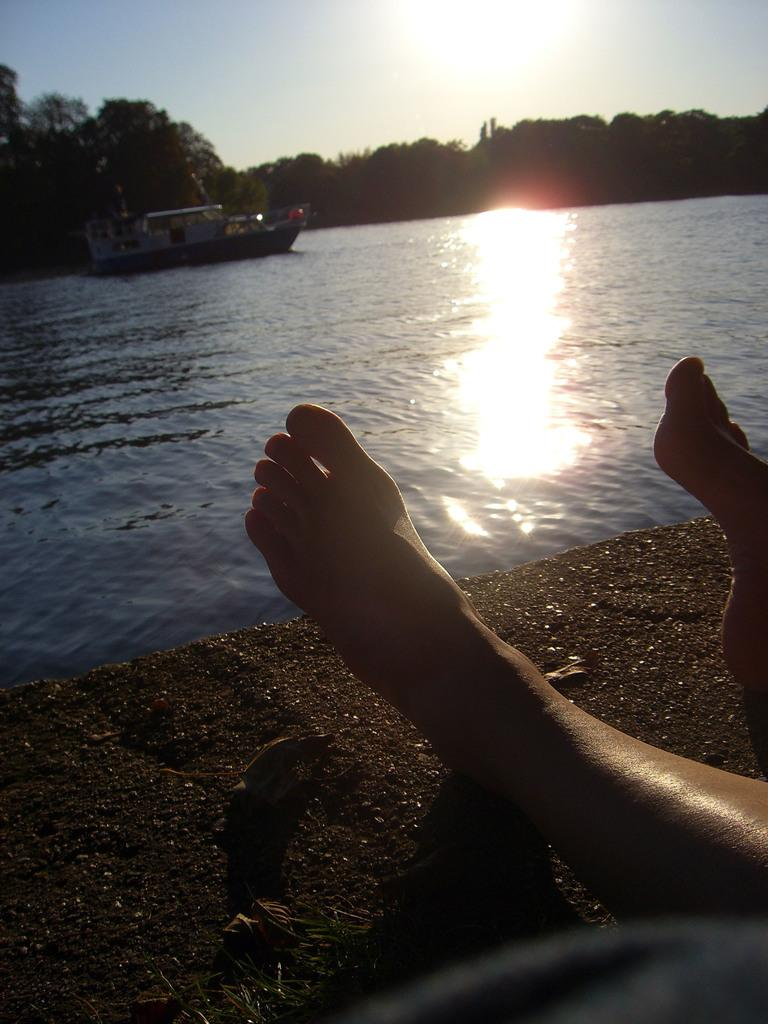What part of a person can be seen in the image? There is a person's leg in the image. What is on the ground in the image? Dry leaves are present on the ground. What is the water in the image used for? The water is being used by a ship that is floating on it. What can be seen in the background of the image? Trees, the sun, and the sky are visible in the background of the image. What type of oil can be seen dripping from the trees in the image? There is no oil present in the image; only dry leaves, water, a ship, trees, the sun, and the sky are visible. 